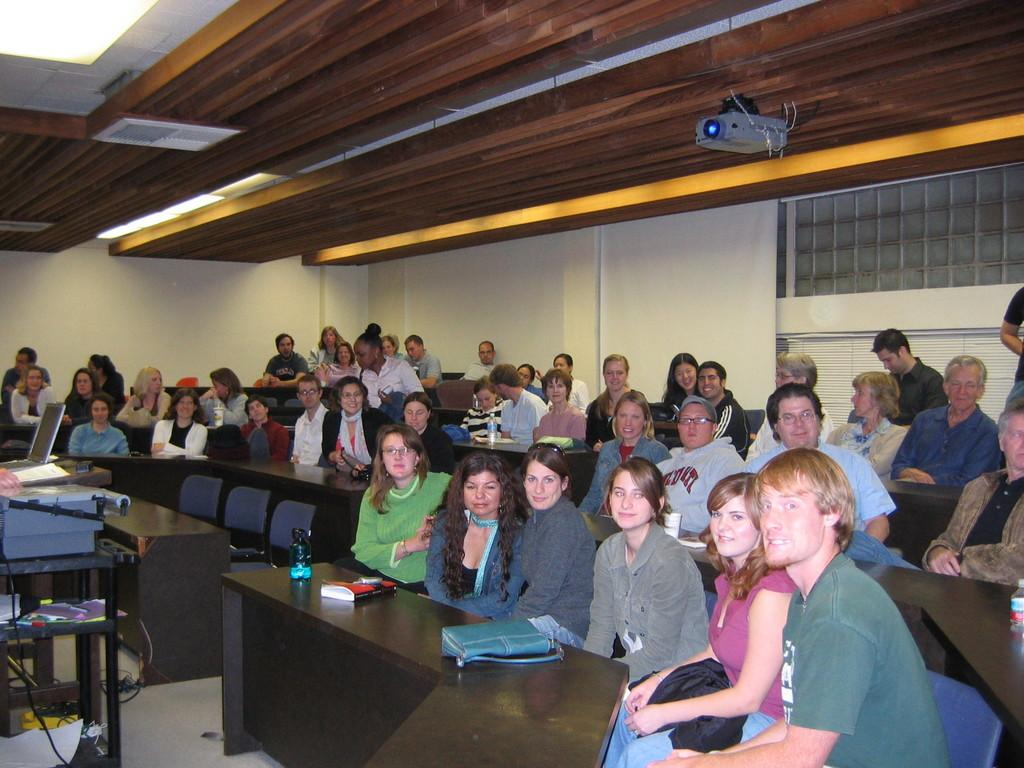How many people are present in the image? There are a lot of people in the image. What are the people doing in the image? The people are sitting on chairs. How many snakes are slithering around the people in the image? There are no snakes present in the image; the people are sitting on chairs. What type of copy machine is visible in the image? There is no copy machine present in the image; it only shows people sitting on chairs. 